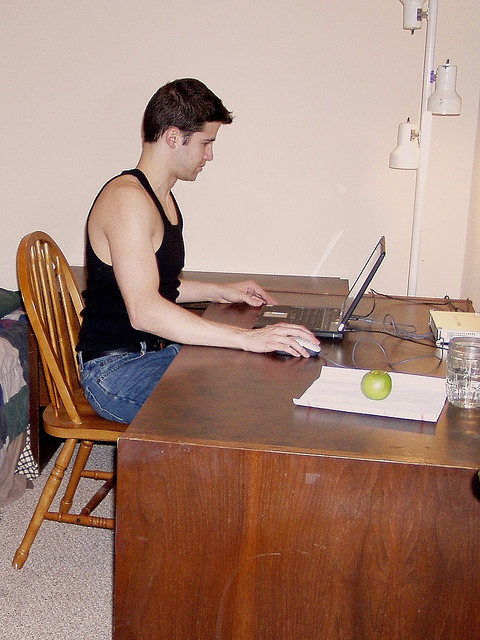Describe the objects in this image and their specific colors. I can see people in lightgray, black, and tan tones, chair in lightgray, brown, maroon, black, and darkgray tones, book in lightgray, khaki, olive, and darkgray tones, laptop in lightgray, gray, and black tones, and cup in lightgray, darkgray, and gray tones in this image. 